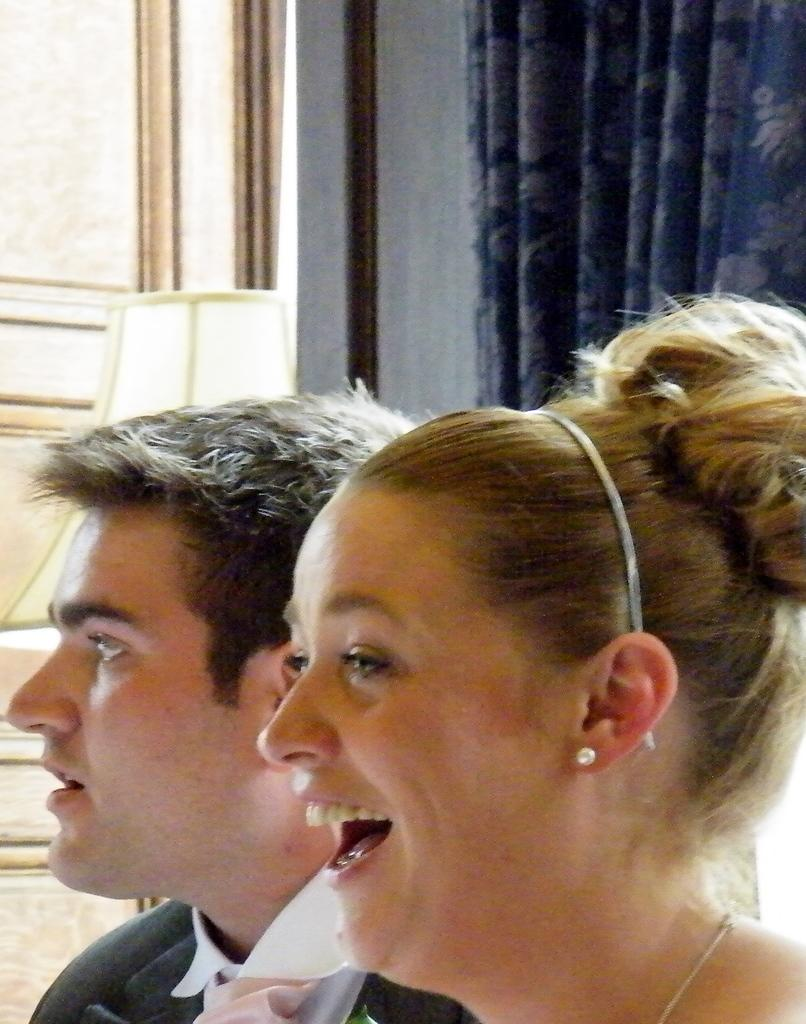Who are the people in the image? There is a man and a woman in the image. What is the woman doing in the image? The woman is smiling in the image. What can be seen in the background of the image? There is a white cloth in the background of the image. What type of cloud can be seen in the image? There is no cloud present in the image. What role does the minister play in the image? There is no minister present in the image. 